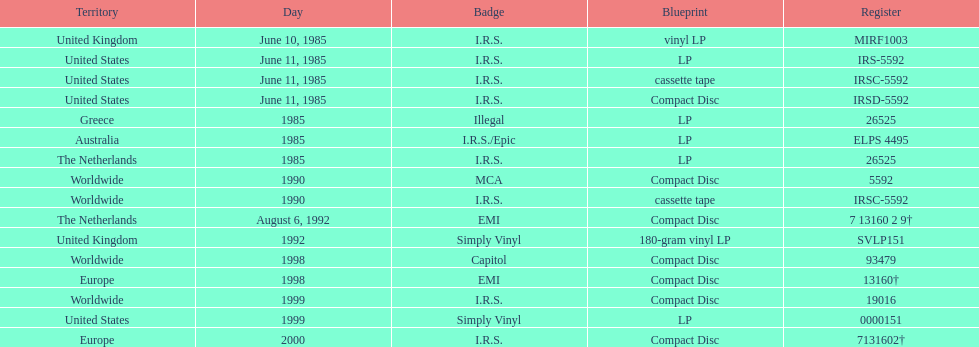Can you provide at least two labels responsible for releasing the group's albums? I.R.S., Illegal. 